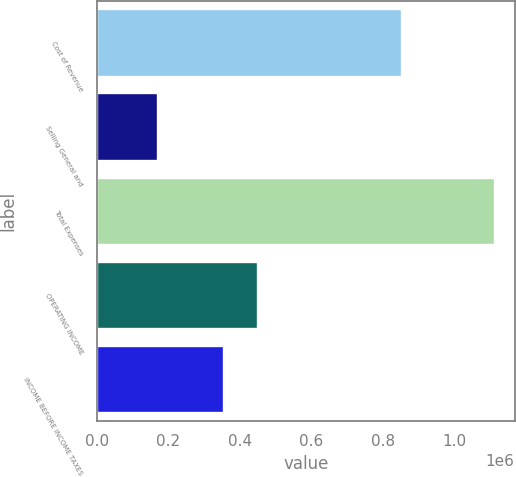<chart> <loc_0><loc_0><loc_500><loc_500><bar_chart><fcel>Cost of Revenue<fcel>Selling General and<fcel>Total Expenses<fcel>OPERATING INCOME<fcel>INCOME BEFORE INCOME TAXES<nl><fcel>853138<fcel>171710<fcel>1.11329e+06<fcel>450316<fcel>356158<nl></chart> 